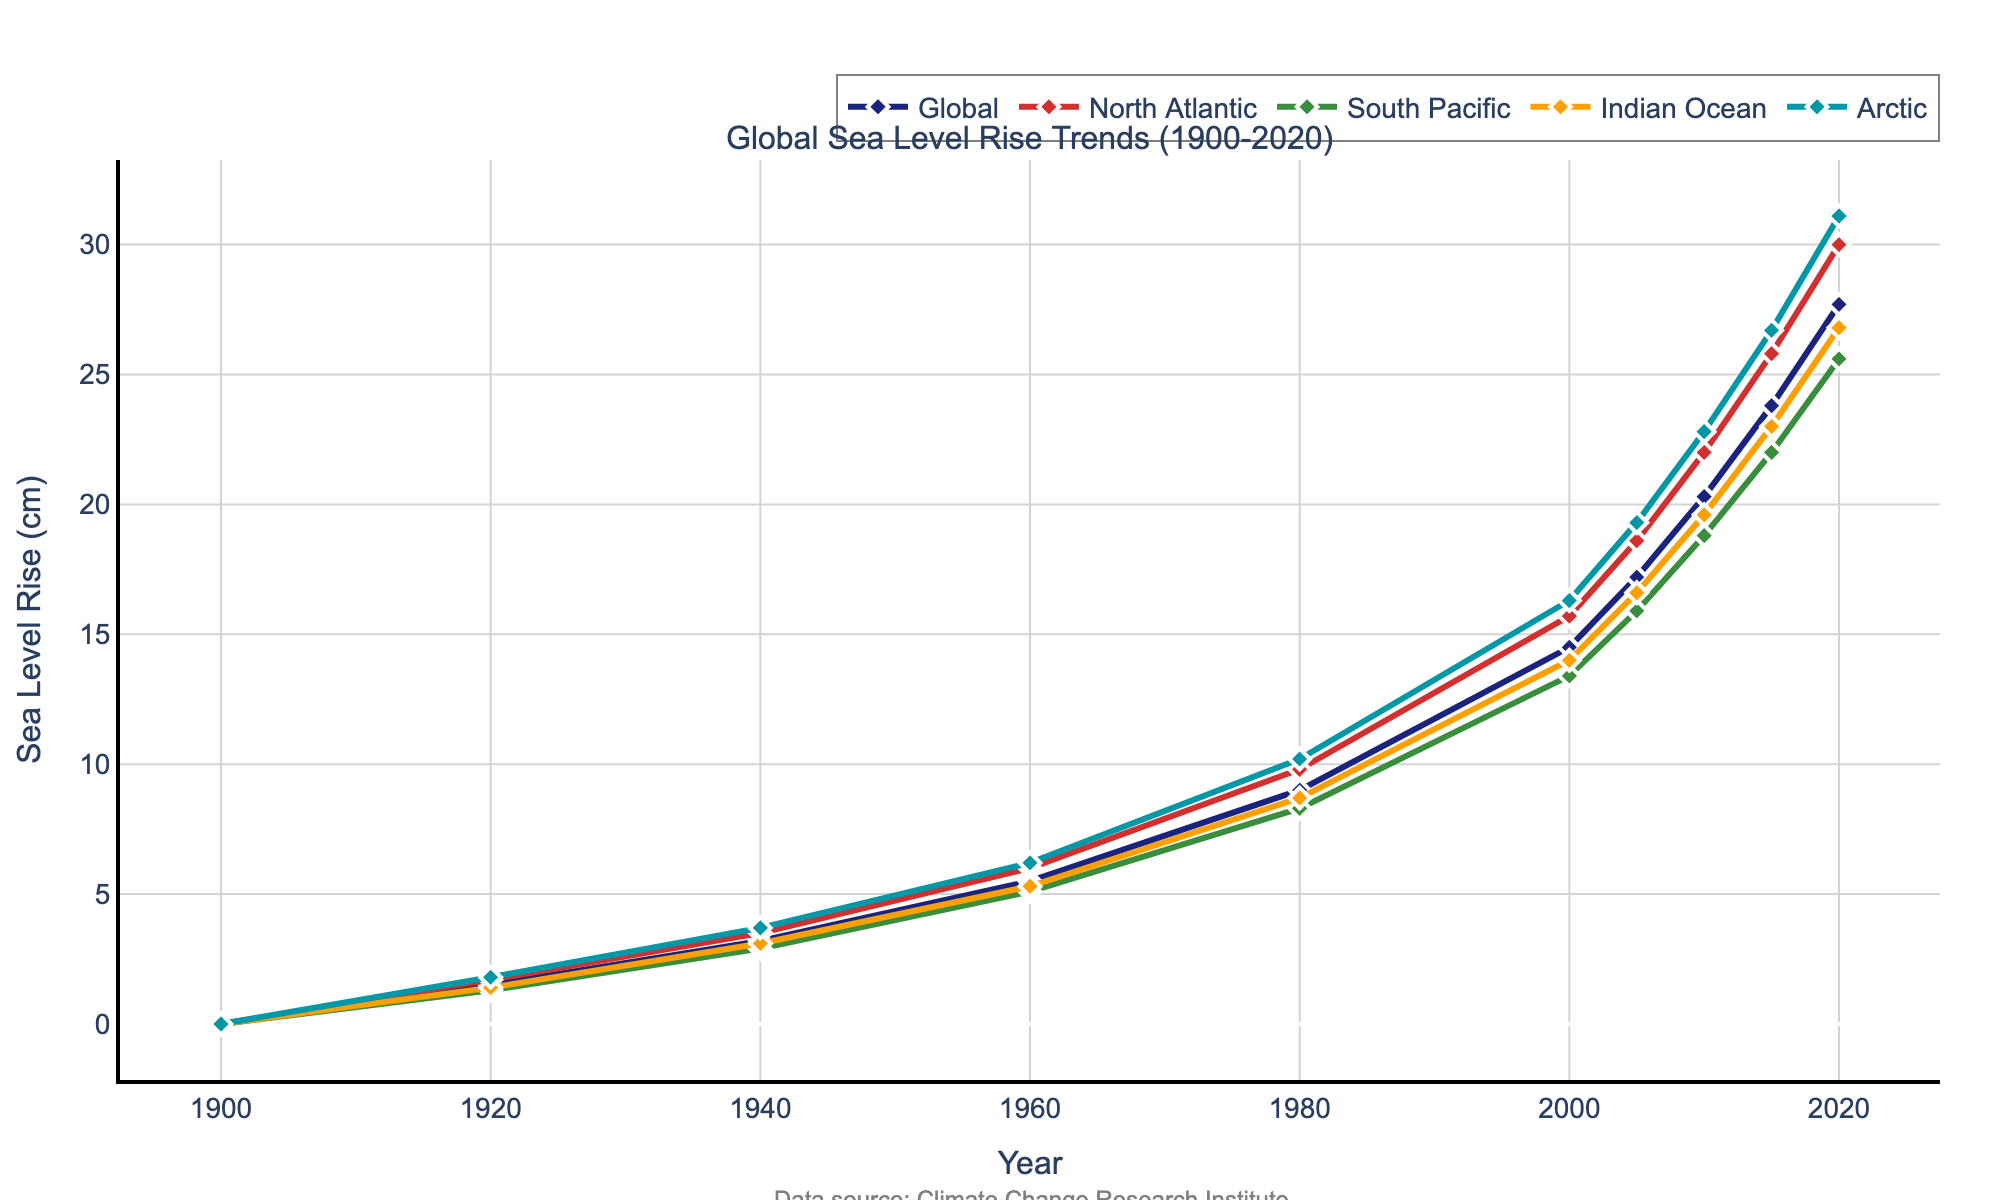What is the overall trend of the global sea level rise from 1900 to 2020? To determine the overall trend, observe the global sea level rise line from 1900 to 2020. The line shows a continuous upward trend, indicating a steady increase in sea level over time.
Answer: Steadily increasing Which region shows the highest sea level rise in 2020? To find the region with the highest sea level rise in 2020, look at the endpoints of the lines for each region on the right side of the plot. The Arctic region line is highest at approximately 31.1 cm.
Answer: Arctic What is the difference in sea level rise between the North Atlantic and South Pacific regions in 2020? Look at the 2020 data points for the North Atlantic and South Pacific regions. North Atlantic is at 30.0 cm and South Pacific is at 25.6 cm. Subtract the South Pacific value from the North Atlantic value (30.0 - 25.6).
Answer: 4.4 cm During which decade did the global sea level rise see the largest increase? Examine the intervals between the points on the global sea level rise line. Notice the largest vertical gap between consecutive points, which is between the years 2000 and 2010.
Answer: 2000-2010 What is the average sea level rise in the Indian Ocean across the entire period from 1900 to 2020? Add the Indian Ocean values for all years (0 + 1.4 + 3.1 + 5.3 + 8.7 + 14.0 + 16.6 + 19.6 + 23.0 + 26.8). Then divide by the number of data points (10). The sum is 118.5. Divide by 10.
Answer: 11.85 cm How does the sea level rise in the Arctic in 1940 compare to the South Pacific in the same year? Look at the 1940 data points for the Arctic and South Pacific. Arctic is at 3.7 cm and South Pacific is at 2.9 cm. Compare the values; Arctic is higher by (3.7 - 2.9).
Answer: 0.8 cm higher Which region had the smallest increase in sea level rise from 1900 to 2020? Calculate the increase for each region by subtracting the 1900 value from the 2020 value. Global: 27.7, North Atlantic: 30.0, South Pacific: 25.6, Indian Ocean: 26.8, Arctic: 31.1. The South Pacific region has the smallest increase (25.6).
Answer: South Pacific In what year did the global sea level rise exceed 10 cm for the first time? Look at the global sea level rise line and find the year where it first exceeds 10 cm. This occurs just before 2000.
Answer: Just before 2000 By how much did the sea level rise in the North Atlantic region change from 1960 to 1980? Look at the 1960 and 1980 data points for the North Atlantic. In 1960 it is at 6.0 cm; in 1980 it is at 9.8 cm. Calculate the difference (9.8 - 6.0).
Answer: 3.8 cm 